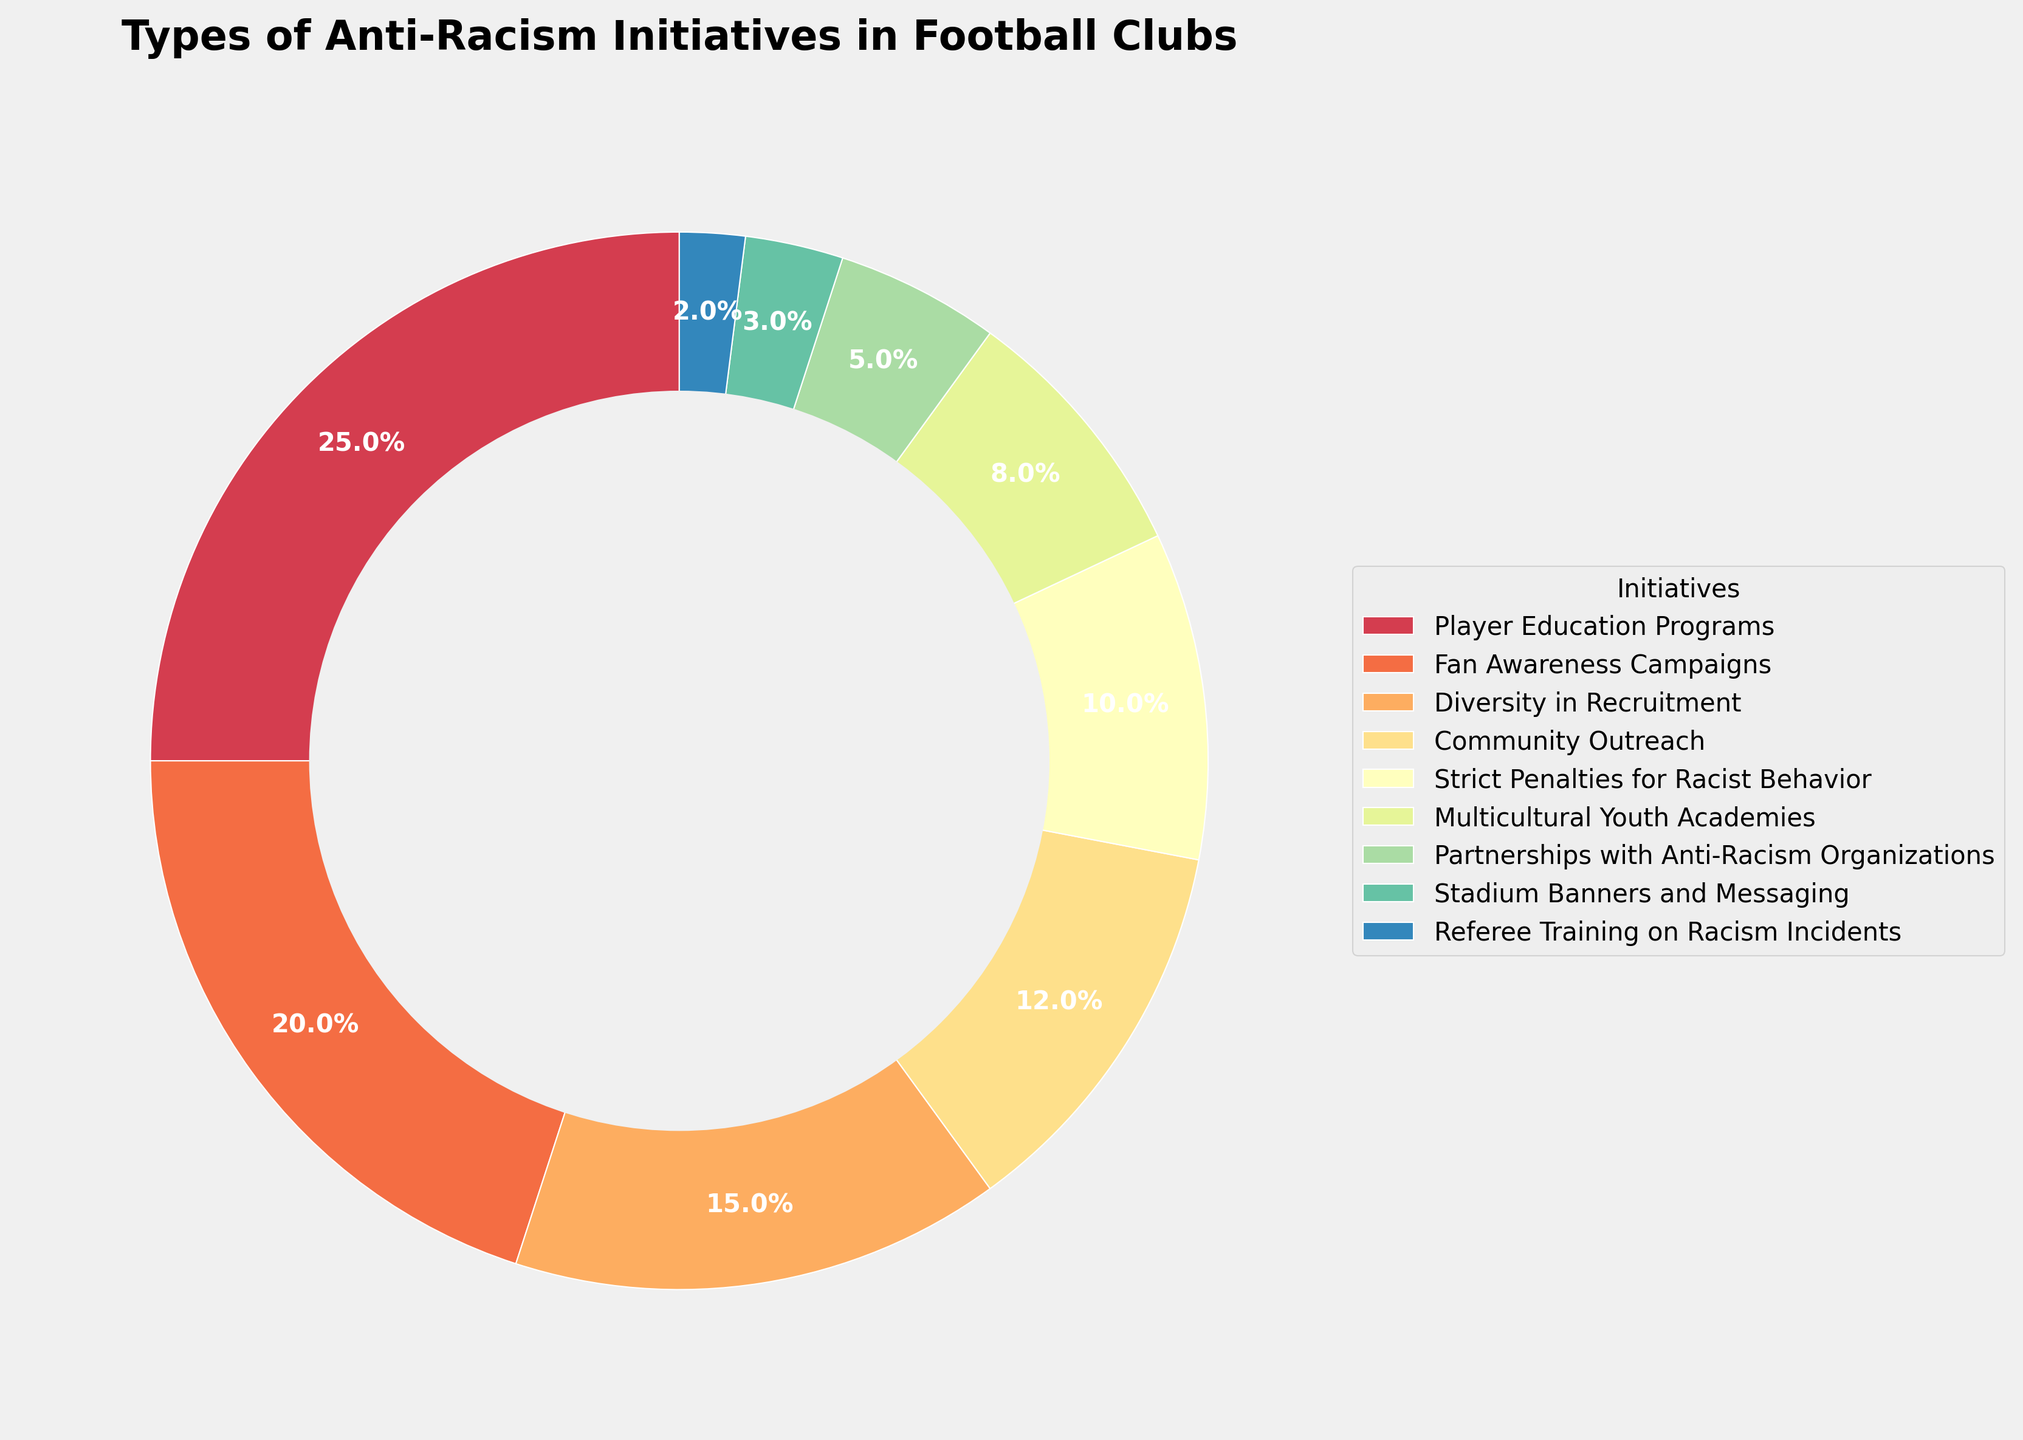What percentage of anti-racism initiatives implemented by football clubs involve working with external organizations? Look for the "Partnerships with Anti-Racism Organizations" segment in the pie chart and note its percentage.
Answer: 5% Which initiative has the largest share in the pie chart? Identify the segment with the highest percentage. The largest segment corresponds to "Player Education Programs" with 25%.
Answer: Player Education Programs How do the percentages of "Fan Awareness Campaigns" and "Community Outreach" initiatives compare? Find the percentages for both "Fan Awareness Campaigns" (20%) and "Community Outreach" (12%) and compare them.
Answer: Fan Awareness Campaigns are higher What is the combined percentage of "Strict Penalties for Racist Behavior" and "Diversity in Recruitment"? Add the percentages of "Strict Penalties for Racist Behavior" (10%) and "Diversity in Recruitment" (15%). 10% + 15% = 25%
Answer: 25% Are there more initiatives focused on youth or fan awareness, based on their percentages? Compare the percentages of "Multicultural Youth Academies" (8%) and "Fan Awareness Campaigns" (20%) to see which is higher.
Answer: Fan Awareness Campaigns Combine the percentage of three smallest initiatives. What is the total percentage share? Add the percentages of the three smallest initiatives: "Referee Training on Racism Incidents" (2%), "Stadium Banners and Messaging" (3%), and "Partnerships with Anti-Racism Organizations" (5%). 2% + 3% + 5% = 10%
Answer: 10% Which initiative represents the second smallest segment? Identify the segment with the second smallest percentage, which is "Stadium Banners and Messaging" at 3%.
Answer: Stadium Banners and Messaging What is the difference in percentage between "Community Outreach" and "Multicultural Youth Academies"? Subtract the percentage of "Multicultural Youth Academies" (8%) from "Community Outreach" (12%). 12% - 8% = 4%
Answer: 4% If "Multicultural Youth Academies" and "Referee Training on Racism Incidents" were combined, would they surpass "Fan Awareness Campaigns" in percentage? Add the percentages of "Multicultural Youth Academies" (8%) and "Referee Training on Racism Incidents" (2%) and compare to "Fan Awareness Campaigns" (20%). 8% + 2% = 10% which is less than 20%
Answer: No Identify all initiatives that together make up half the total percentage. Identify the initiatives that collectively make up 50%: "Player Education Programs" (25%) and "Fan Awareness Campaigns" (20%) together sum up to 45%. Including "Diversity in Recruitment" (15%) gives a total of 60%, which exceeds 50%. Therefore, "Player Education Programs" (25%) and "Fan Awareness Campaigns" (20%) themselves do not make half but get close.
Answer: Player Education Programs, Fan Awareness Campaigns, Diversity in Recruitment 